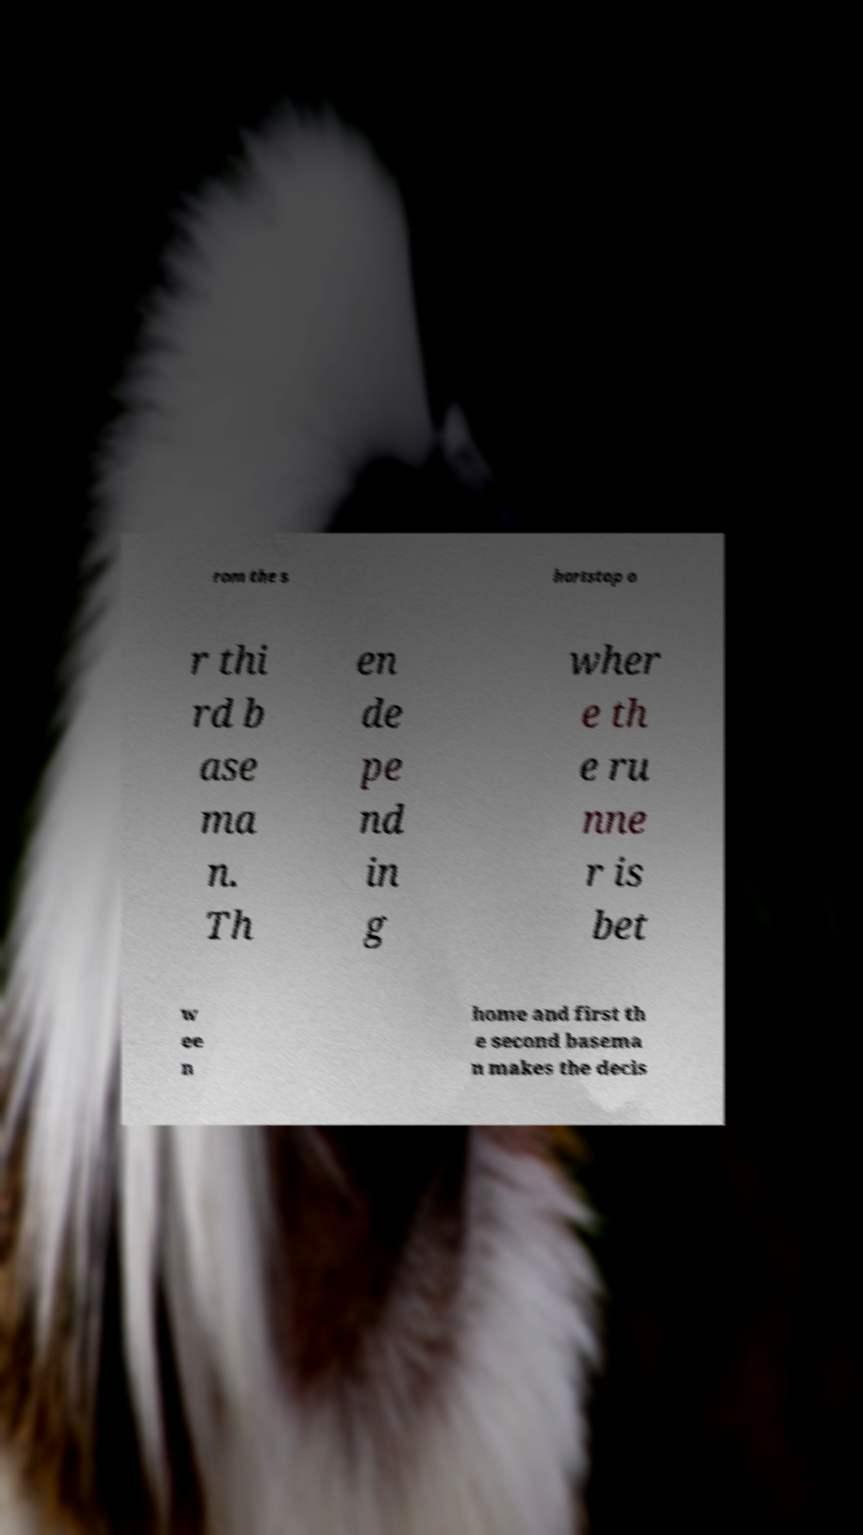Could you assist in decoding the text presented in this image and type it out clearly? rom the s hortstop o r thi rd b ase ma n. Th en de pe nd in g wher e th e ru nne r is bet w ee n home and first th e second basema n makes the decis 